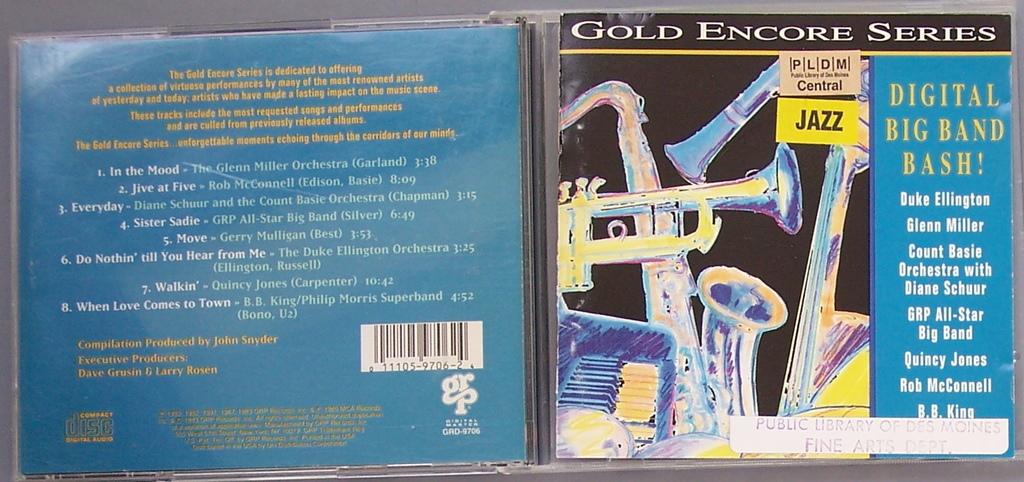What kind of series is this?
Provide a short and direct response. Gold encore. What kind of music does the cd contain?
Keep it short and to the point. Jazz. 